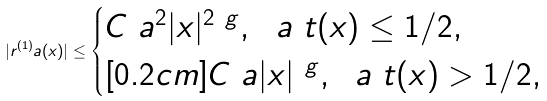Convert formula to latex. <formula><loc_0><loc_0><loc_500><loc_500>| r ^ { ( 1 ) } _ { \ } a ( x ) | \leq \begin{cases} C \ a ^ { 2 } | x | ^ { 2 \ g } , \ \ a \ t ( x ) \leq 1 / 2 , \\ [ 0 . 2 c m ] C \ a | x | ^ { \ g } , \ \ a \ t ( x ) > 1 / 2 , \end{cases}</formula> 